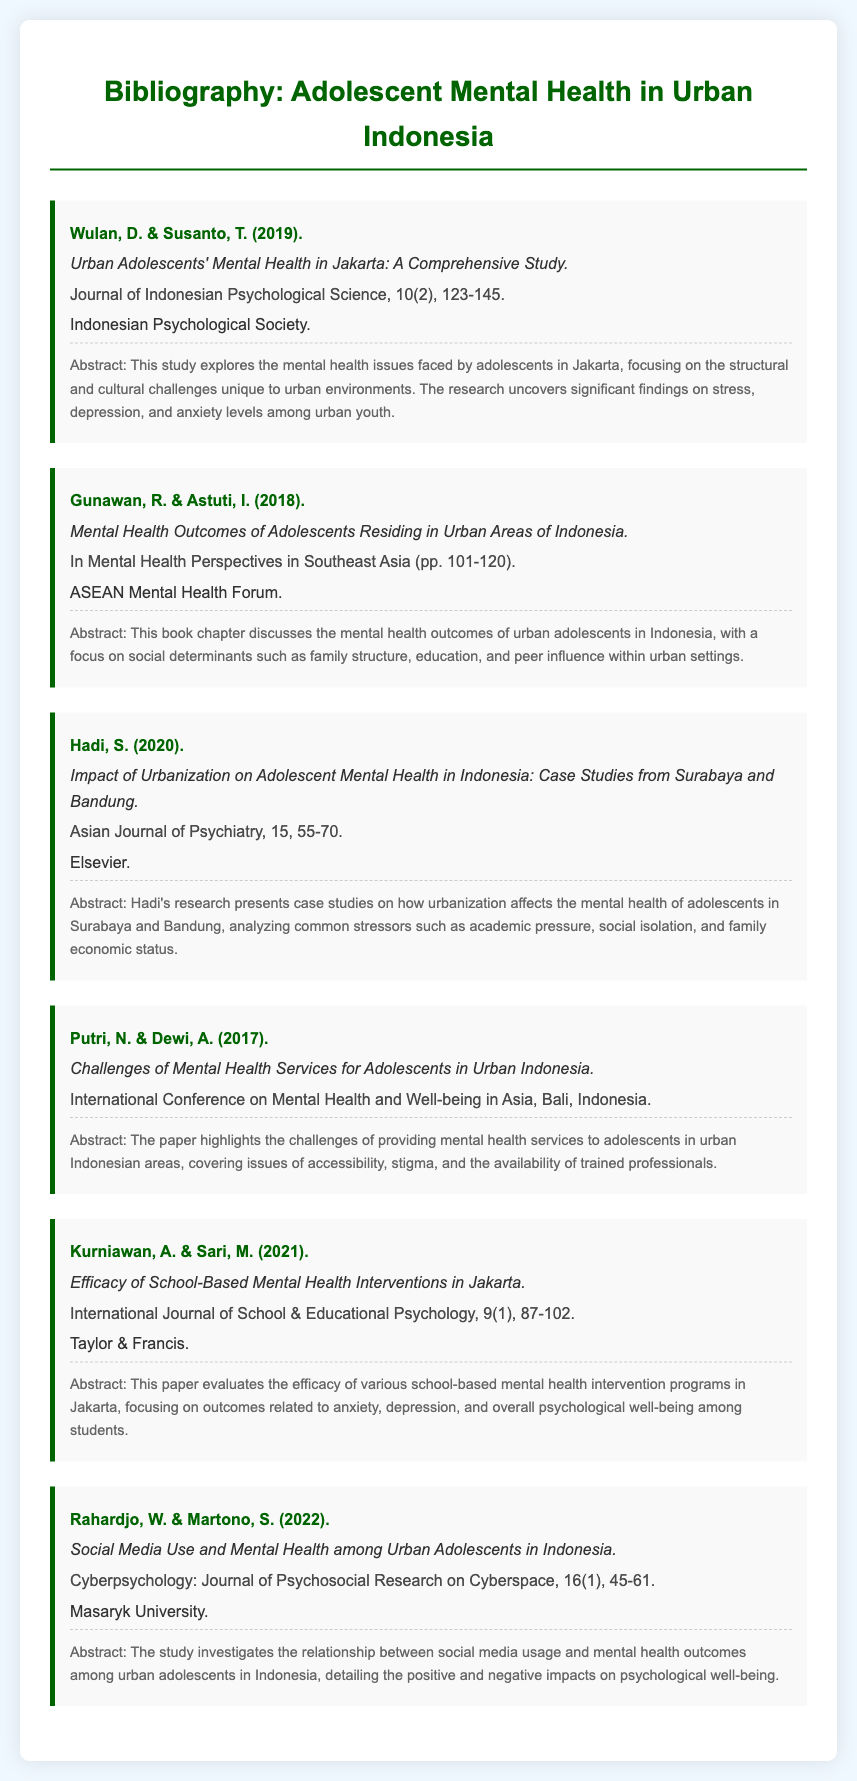What is the title of Wulan and Susanto's study? The title of the study by Wulan and Susanto is found in the document under their entry, which explicitly states it.
Answer: Urban Adolescents' Mental Health in Jakarta: A Comprehensive Study What year was the article by Hadi published? The year of publication for Hadi's article is listed in the bibliographic entry under the author’s name.
Answer: 2020 What is the focus of Gunawan and Astuti's book chapter? The focus of their chapter can be inferred from the abstract, which summarizes the key topics covered in the document.
Answer: Social determinants of mental health outcomes What is the volume number of the journal where Kurniawan and Sari's paper was published? The volume number is mentioned in the journal's citation in their entry.
Answer: 9 Which two cities are analyzed in Hadi's case studies? The cities investigated in Hadi's research are detailed in the title of the article in the document.
Answer: Surabaya and Bandung What do Putri and Dewi discuss in their conference paper? The main topic of discussion is outlined in their abstract, which summarizes the issues they explore.
Answer: Challenges of providing mental health services What is the publication type of the work by Rahardjo and Martono? The type of publication is indicated in the citation of their entry.
Answer: Journal article 